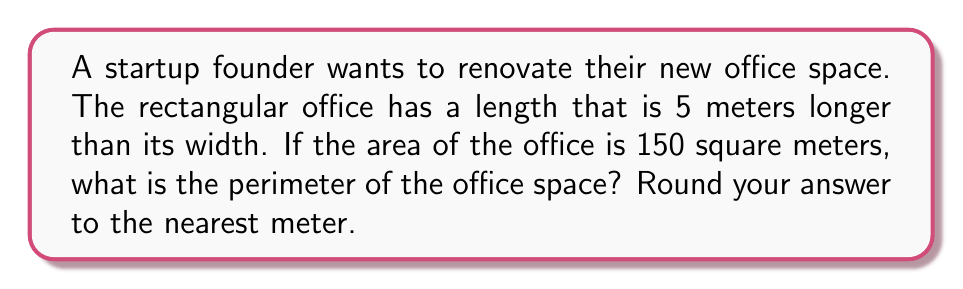Give your solution to this math problem. Let's approach this step-by-step:

1) Let's define our variables:
   $w$ = width of the office
   $l$ = length of the office

2) We're told that the length is 5 meters longer than the width:
   $l = w + 5$

3) We're also given that the area is 150 square meters:
   $A = l * w = 150$

4) Substituting the length equation into the area equation:
   $(w + 5) * w = 150$

5) Expand this:
   $w^2 + 5w = 150$

6) Rearrange to standard quadratic form:
   $w^2 + 5w - 150 = 0$

7) We can solve this using the quadratic formula: $w = \frac{-b \pm \sqrt{b^2 - 4ac}}{2a}$
   Where $a = 1$, $b = 5$, and $c = -150$

8) Plugging in:
   $w = \frac{-5 \pm \sqrt{5^2 - 4(1)(-150)}}{2(1)} = \frac{-5 \pm \sqrt{625}}{2} = \frac{-5 \pm 25}{2}$

9) This gives us two solutions: $w = 10$ or $w = -15$
   Since width can't be negative, $w = 10$

10) If $w = 10$, then $l = 10 + 5 = 15$

11) The perimeter of a rectangle is given by $P = 2l + 2w$

12) Substituting our values:
    $P = 2(15) + 2(10) = 30 + 20 = 50$

Therefore, the perimeter of the office space is 50 meters.
Answer: 50 meters 